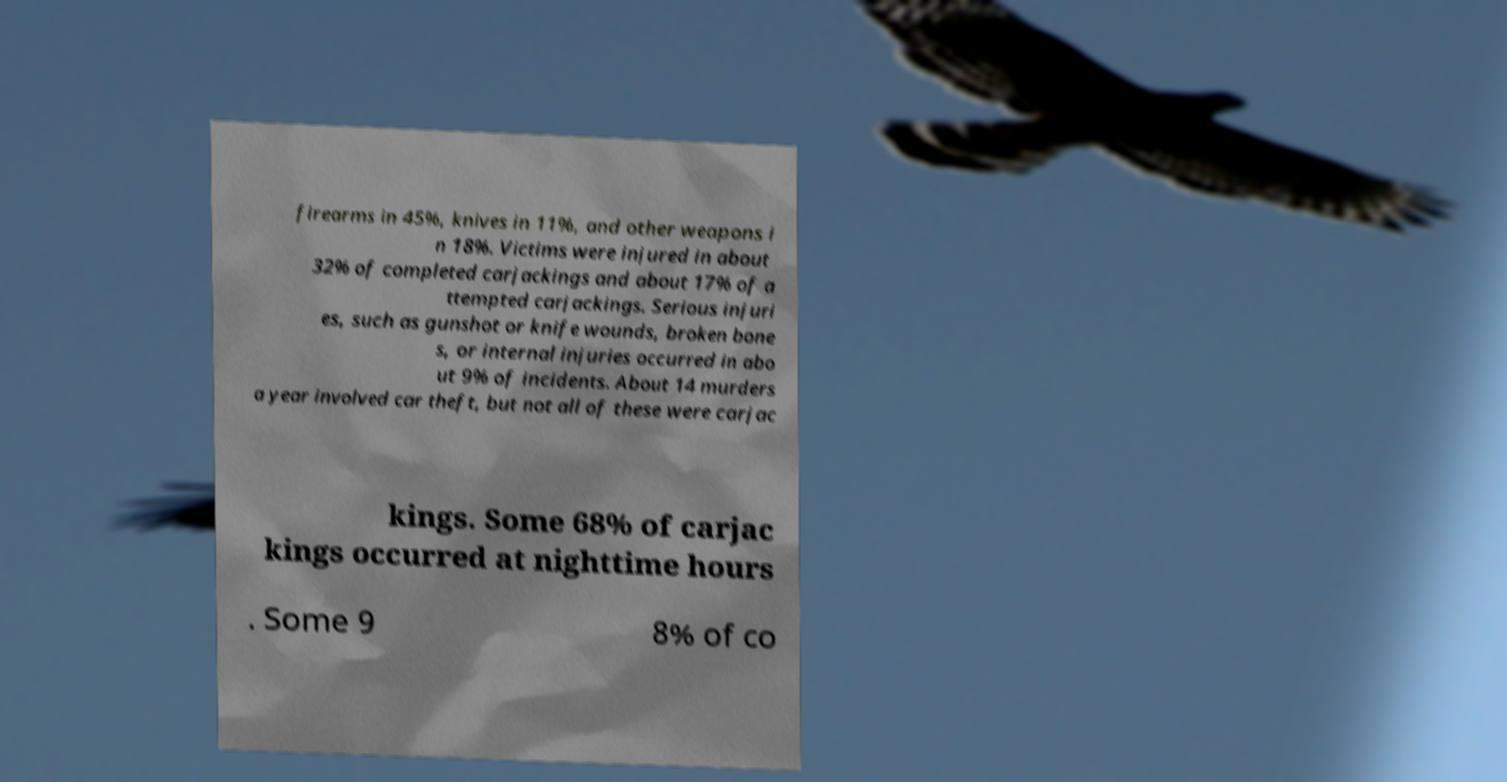There's text embedded in this image that I need extracted. Can you transcribe it verbatim? firearms in 45%, knives in 11%, and other weapons i n 18%. Victims were injured in about 32% of completed carjackings and about 17% of a ttempted carjackings. Serious injuri es, such as gunshot or knife wounds, broken bone s, or internal injuries occurred in abo ut 9% of incidents. About 14 murders a year involved car theft, but not all of these were carjac kings. Some 68% of carjac kings occurred at nighttime hours . Some 9 8% of co 